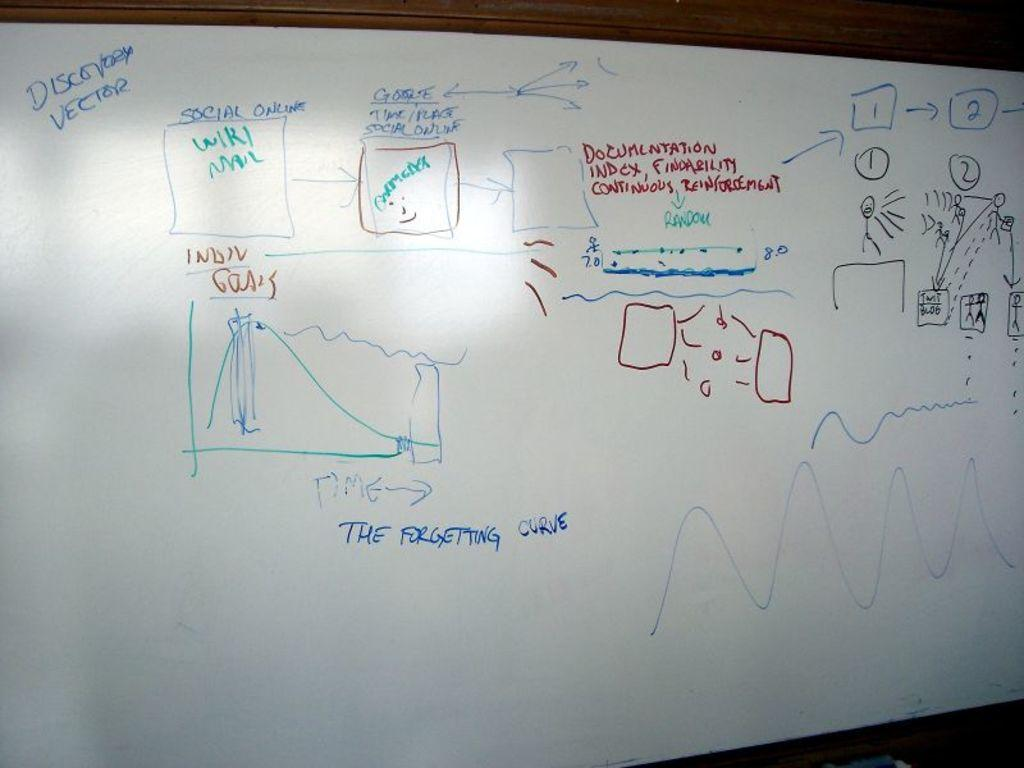<image>
Present a compact description of the photo's key features. a white board has a lesson, including the forgetting curve, written on it 